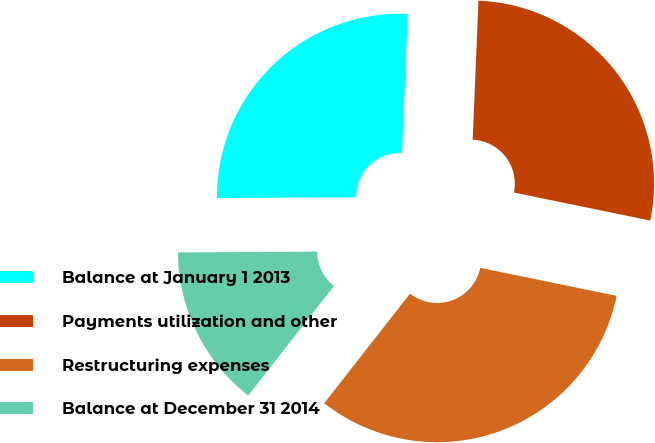Convert chart. <chart><loc_0><loc_0><loc_500><loc_500><pie_chart><fcel>Balance at January 1 2013<fcel>Payments utilization and other<fcel>Restructuring expenses<fcel>Balance at December 31 2014<nl><fcel>25.76%<fcel>27.56%<fcel>32.35%<fcel>14.33%<nl></chart> 